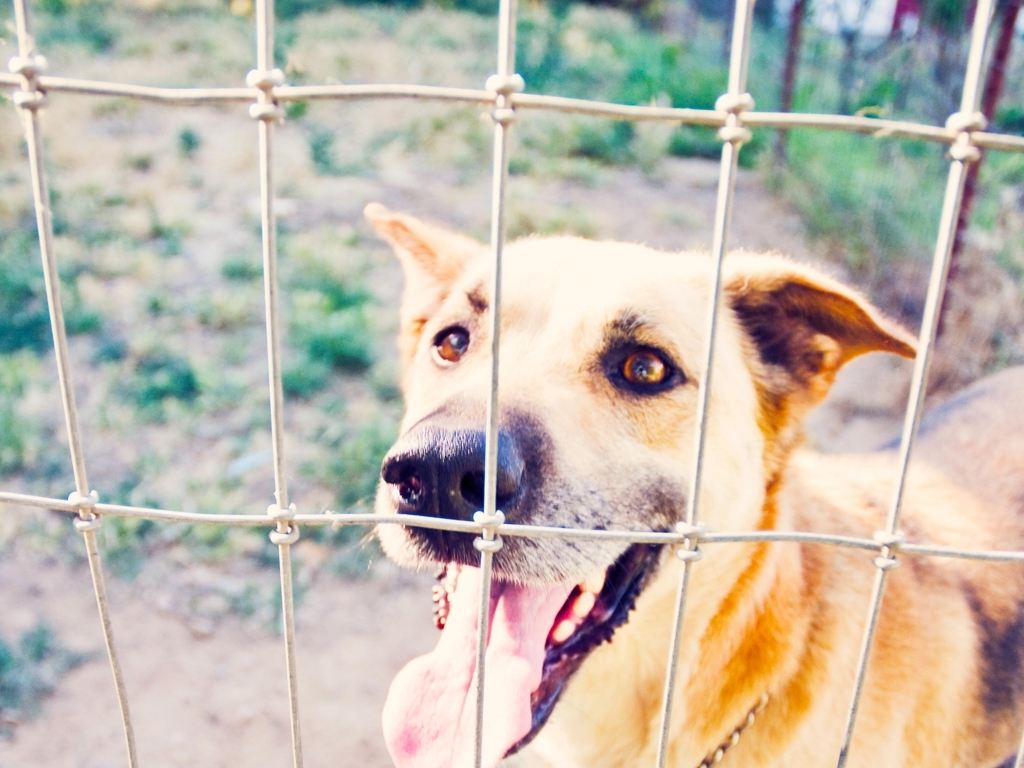Is the clarity of the photo acceptable? The clarity of the photo is satisfactory as the subject, a dog behind a fence, is in focus and easily recognizable. The colors are vibrant, and the depth of field isolates the dog from the background, although there is a slight blur which is artistic and does not detract from the quality of the image. 